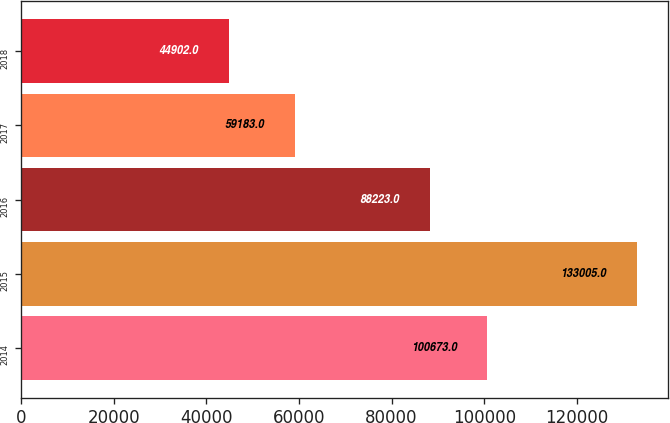Convert chart to OTSL. <chart><loc_0><loc_0><loc_500><loc_500><bar_chart><fcel>2014<fcel>2015<fcel>2016<fcel>2017<fcel>2018<nl><fcel>100673<fcel>133005<fcel>88223<fcel>59183<fcel>44902<nl></chart> 